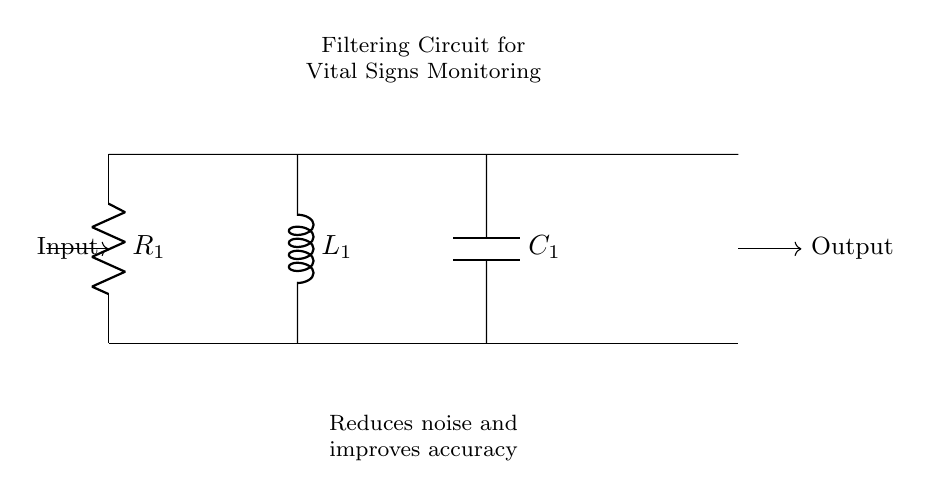What components are in this circuit? The circuit contains a resistor, an inductor, and a capacitor, which are designated as R1, L1, and C1 respectively.
Answer: Resistor, Inductor, Capacitor What is the purpose of the filtering circuit? The purpose of the filtering circuit is to reduce noise in the signal and improve the accuracy of the vital signs monitoring equipment, as stated in the description.
Answer: Reduce noise, improve accuracy How many components are in the circuit? There are three components in total: one resistor, one inductor, and one capacitor.
Answer: Three Which component is directly connected to the input? The resistor R1 is directly connected to the input of the circuit, as seen at the top left corner of the diagram.
Answer: R1 What type of filter is represented by a resistor, inductor, and capacitor in series? The series combination of a resistor, inductor, and capacitor typically forms a band-pass filter that allows certain frequencies to pass while attenuating others.
Answer: Band-pass filter What happens to high-frequency signals in this circuit? High-frequency signals are attenuated or filtered out due to the combined effects of the inductor and capacitor, which block these frequencies, ensuring only lower frequencies contribute to the output.
Answer: Attenuated What is the relationship between the components in terms of impedance? The impedance in this circuit involves the resistive, inductive, and capacitive components where the total impedance can vary with frequency, consequently affecting the filtering characteristics.
Answer: Frequency-dependent impedance 